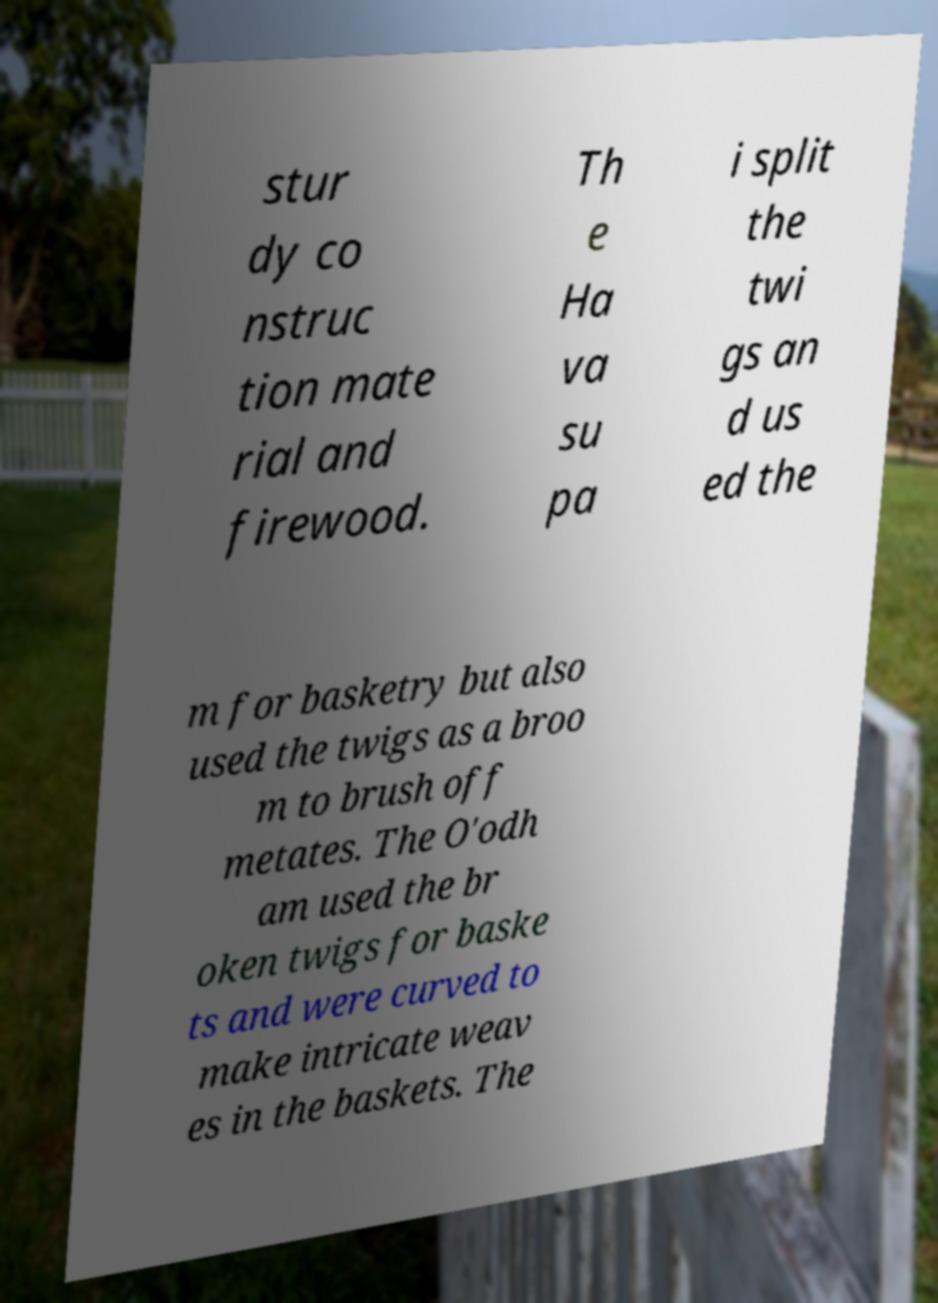Please read and relay the text visible in this image. What does it say? stur dy co nstruc tion mate rial and firewood. Th e Ha va su pa i split the twi gs an d us ed the m for basketry but also used the twigs as a broo m to brush off metates. The O'odh am used the br oken twigs for baske ts and were curved to make intricate weav es in the baskets. The 